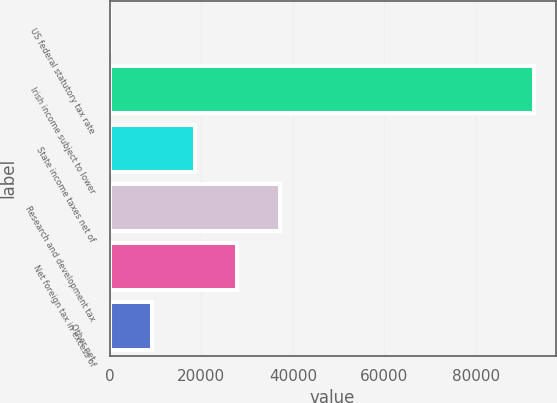<chart> <loc_0><loc_0><loc_500><loc_500><bar_chart><fcel>US federal statutory tax rate<fcel>Irish income subject to lower<fcel>State income taxes net of<fcel>Research and development tax<fcel>Net foreign tax in excess of<fcel>Other net<nl><fcel>35<fcel>92732<fcel>18574.4<fcel>37113.8<fcel>27844.1<fcel>9304.7<nl></chart> 